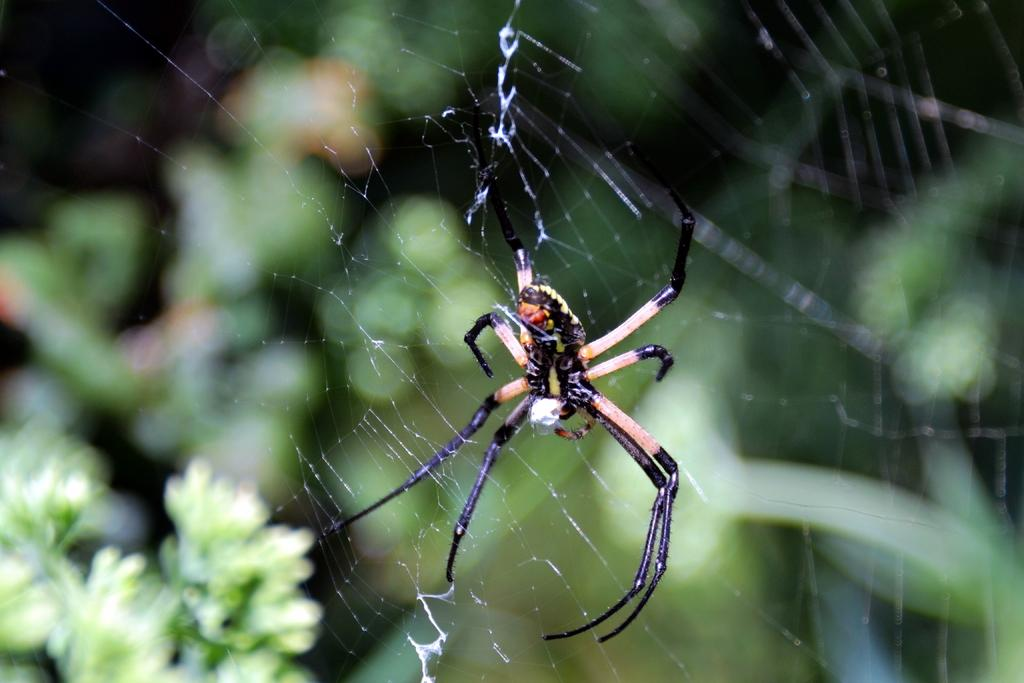What is the main subject of the image? The main subject of the image is a spider's web. Can you describe the background of the image? The background of the image includes plants. What type of punishment is being administered to the spider in the image? There is no spider or punishment present in the image; it only features a spider's web and plants in the background. 